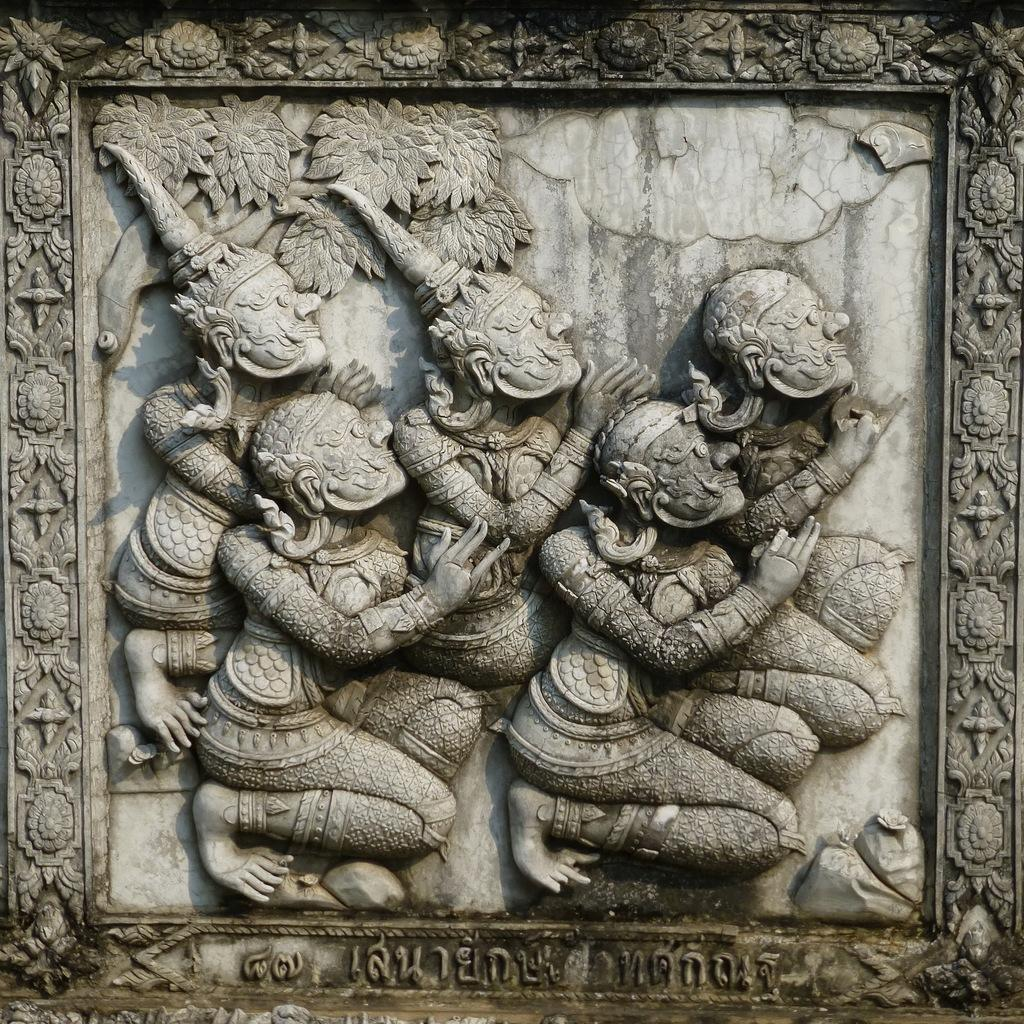What is the main subject of the image? The main subject of the image is a stone carving. What does the stone carving depict? The stone carving depicts several persons. What effect does the stranger's presence have on the stone carving in the image? There is no stranger present in the image, so it is not possible to determine any effect on the stone carving. 